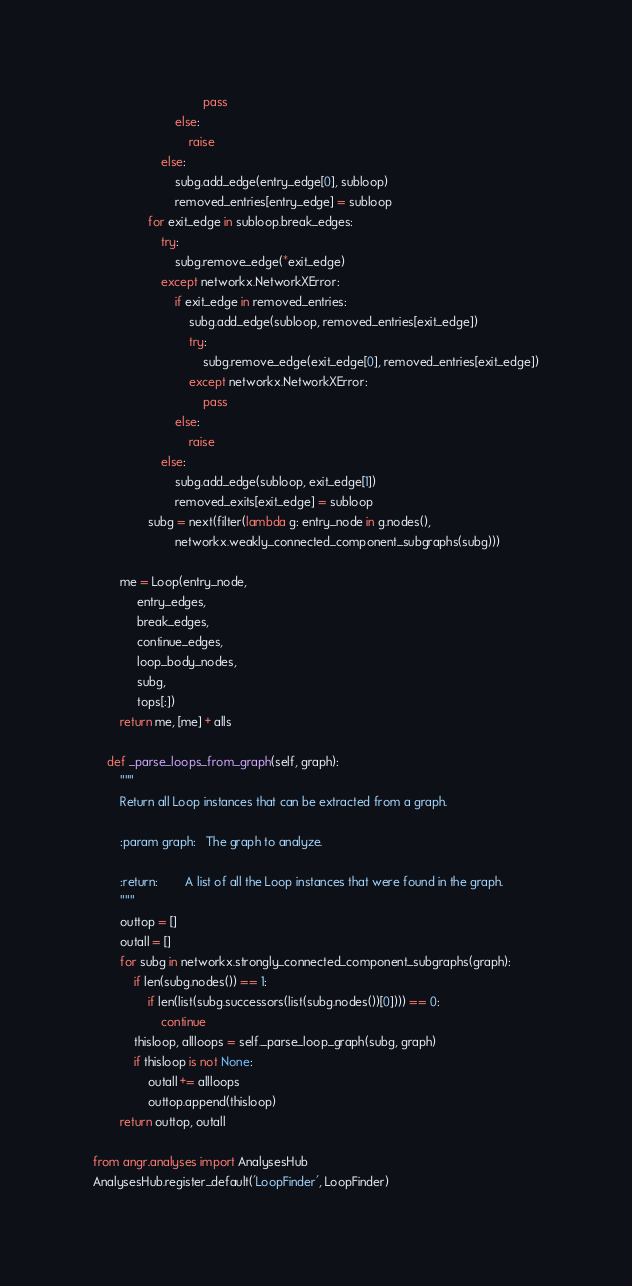<code> <loc_0><loc_0><loc_500><loc_500><_Python_>                                pass
                        else:
                            raise
                    else:
                        subg.add_edge(entry_edge[0], subloop)
                        removed_entries[entry_edge] = subloop
                for exit_edge in subloop.break_edges:
                    try:
                        subg.remove_edge(*exit_edge)
                    except networkx.NetworkXError:
                        if exit_edge in removed_entries:
                            subg.add_edge(subloop, removed_entries[exit_edge])
                            try:
                                subg.remove_edge(exit_edge[0], removed_entries[exit_edge])
                            except networkx.NetworkXError:
                                pass
                        else:
                            raise
                    else:
                        subg.add_edge(subloop, exit_edge[1])
                        removed_exits[exit_edge] = subloop
                subg = next(filter(lambda g: entry_node in g.nodes(),
                        networkx.weakly_connected_component_subgraphs(subg)))

        me = Loop(entry_node,
             entry_edges,
             break_edges,
             continue_edges,
             loop_body_nodes,
             subg,
             tops[:])
        return me, [me] + alls

    def _parse_loops_from_graph(self, graph):
        """
        Return all Loop instances that can be extracted from a graph.

        :param graph:   The graph to analyze.

        :return:        A list of all the Loop instances that were found in the graph.
        """
        outtop = []
        outall = []
        for subg in networkx.strongly_connected_component_subgraphs(graph):
            if len(subg.nodes()) == 1:
                if len(list(subg.successors(list(subg.nodes())[0]))) == 0:
                    continue
            thisloop, allloops = self._parse_loop_graph(subg, graph)
            if thisloop is not None:
                outall += allloops
                outtop.append(thisloop)
        return outtop, outall

from angr.analyses import AnalysesHub
AnalysesHub.register_default('LoopFinder', LoopFinder)
</code> 